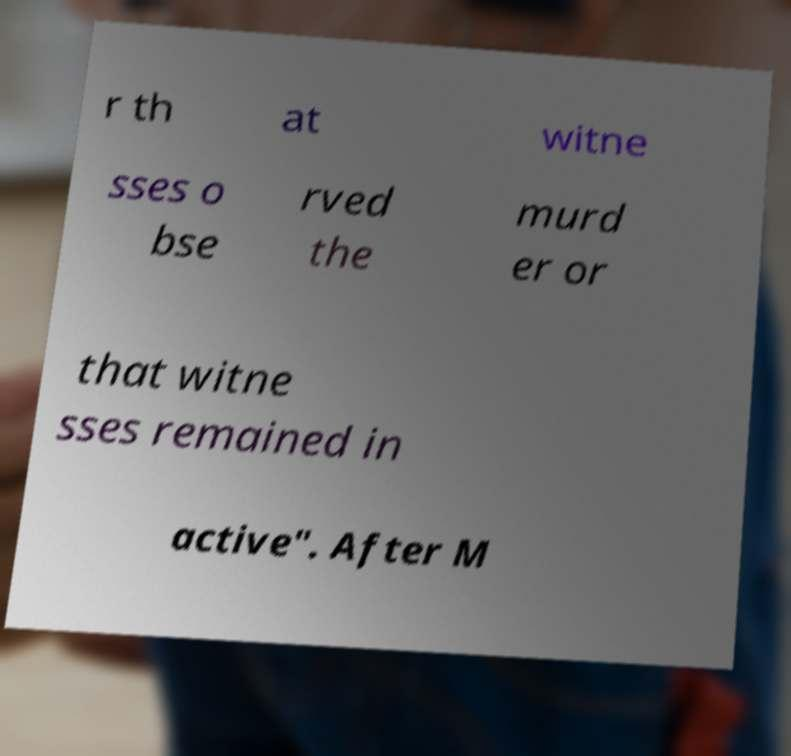I need the written content from this picture converted into text. Can you do that? r th at witne sses o bse rved the murd er or that witne sses remained in active". After M 